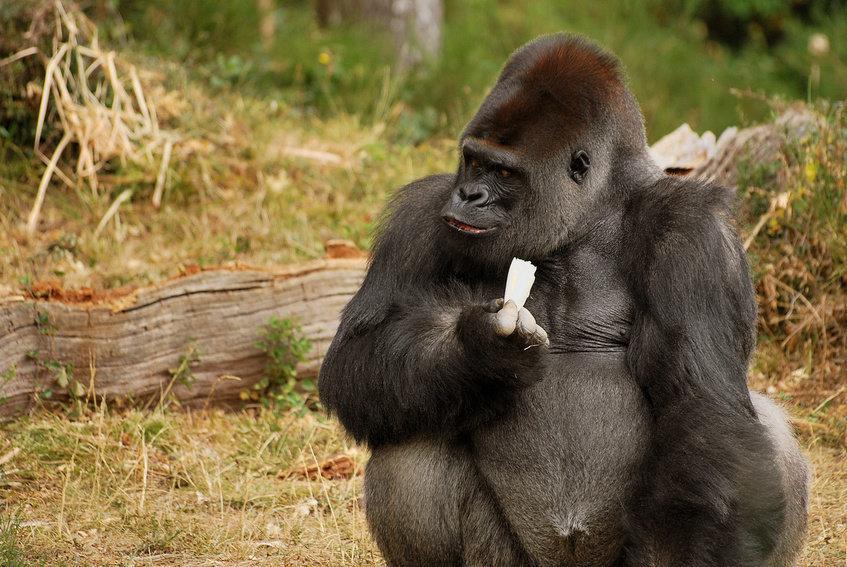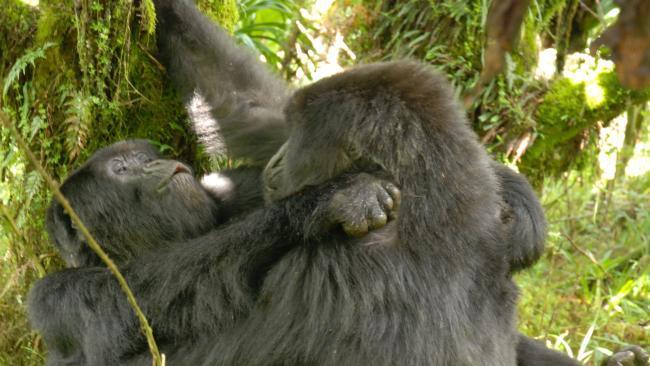The first image is the image on the left, the second image is the image on the right. For the images displayed, is the sentence "An image shows exactly one ape, sitting and holding something in its hand." factually correct? Answer yes or no. Yes. The first image is the image on the left, the second image is the image on the right. Assess this claim about the two images: "There is a single ape holding something in the left image". Correct or not? Answer yes or no. Yes. 